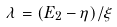<formula> <loc_0><loc_0><loc_500><loc_500>\lambda = ( E _ { 2 } - \eta ) / \xi</formula> 